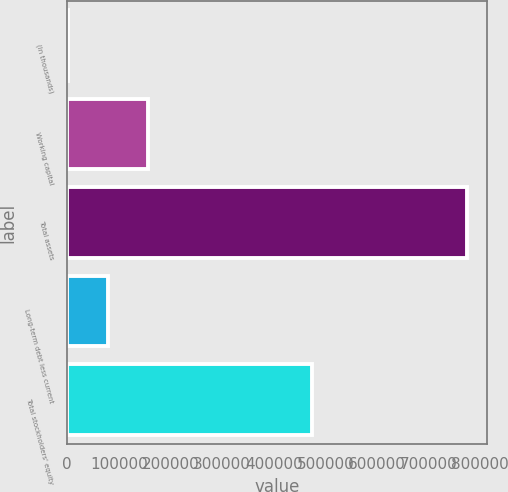Convert chart. <chart><loc_0><loc_0><loc_500><loc_500><bar_chart><fcel>(In thousands)<fcel>Working capital<fcel>Total assets<fcel>Long-term debt less current<fcel>Total stockholders' equity<nl><fcel>2005<fcel>156433<fcel>774146<fcel>79219.1<fcel>474065<nl></chart> 